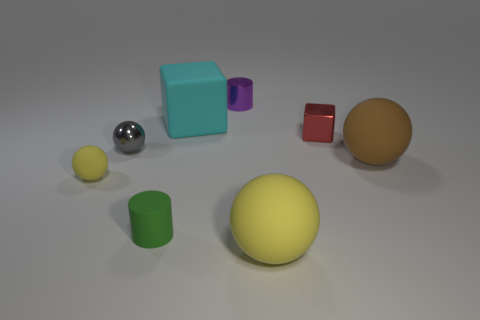There is a brown object that is the same shape as the large yellow object; what material is it? The brown object shares its spherical shape with the larger yellow object, suggesting they could be made of similar materials. Without additional information, it's challenging to determine the exact material from a visual inspection, but common possibilities for such objects include rubber, plastic, or even wood, given the matte finish and shadow indicative of a solid, non-metallic material. 